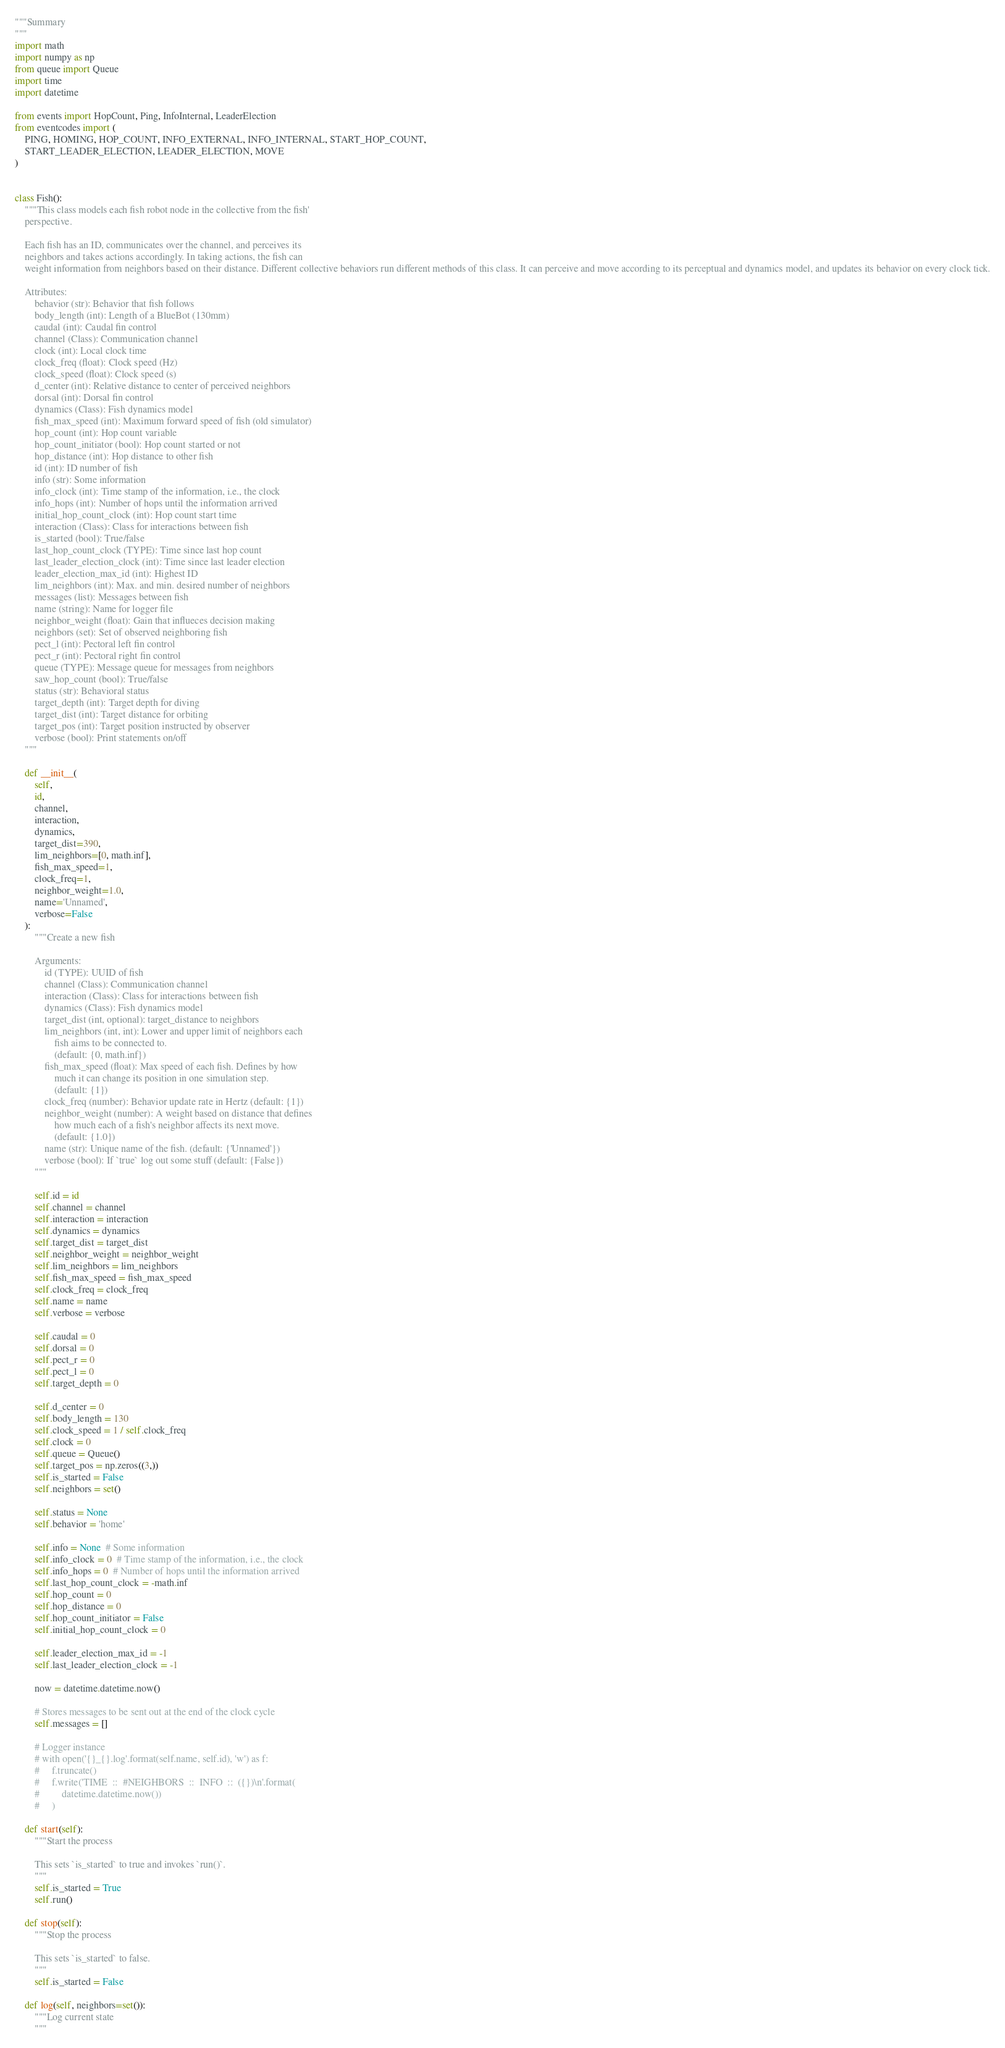<code> <loc_0><loc_0><loc_500><loc_500><_Python_>"""Summary
"""
import math
import numpy as np
from queue import Queue
import time
import datetime

from events import HopCount, Ping, InfoInternal, LeaderElection
from eventcodes import (
    PING, HOMING, HOP_COUNT, INFO_EXTERNAL, INFO_INTERNAL, START_HOP_COUNT,
    START_LEADER_ELECTION, LEADER_ELECTION, MOVE
)


class Fish():
    """This class models each fish robot node in the collective from the fish'
    perspective.

    Each fish has an ID, communicates over the channel, and perceives its
    neighbors and takes actions accordingly. In taking actions, the fish can
    weight information from neighbors based on their distance. Different collective behaviors run different methods of this class. It can perceive and move according to its perceptual and dynamics model, and updates its behavior on every clock tick.

    Attributes:
        behavior (str): Behavior that fish follows
        body_length (int): Length of a BlueBot (130mm)
        caudal (int): Caudal fin control
        channel (Class): Communication channel
        clock (int): Local clock time
        clock_freq (float): Clock speed (Hz)
        clock_speed (float): Clock speed (s)
        d_center (int): Relative distance to center of perceived neighbors
        dorsal (int): Dorsal fin control
        dynamics (Class): Fish dynamics model
        fish_max_speed (int): Maximum forward speed of fish (old simulator)
        hop_count (int): Hop count variable
        hop_count_initiator (bool): Hop count started or not
        hop_distance (int): Hop distance to other fish
        id (int): ID number of fish
        info (str): Some information
        info_clock (int): Time stamp of the information, i.e., the clock
        info_hops (int): Number of hops until the information arrived
        initial_hop_count_clock (int): Hop count start time
        interaction (Class): Class for interactions between fish
        is_started (bool): True/false
        last_hop_count_clock (TYPE): Time since last hop count
        last_leader_election_clock (int): Time since last leader election
        leader_election_max_id (int): Highest ID
        lim_neighbors (int): Max. and min. desired number of neighbors
        messages (list): Messages between fish
        name (string): Name for logger file
        neighbor_weight (float): Gain that influeces decision making
        neighbors (set): Set of observed neighboring fish
        pect_l (int): Pectoral left fin control
        pect_r (int): Pectoral right fin control
        queue (TYPE): Message queue for messages from neighbors
        saw_hop_count (bool): True/false
        status (str): Behavioral status
        target_depth (int): Target depth for diving
        target_dist (int): Target distance for orbiting
        target_pos (int): Target position instructed by observer
        verbose (bool): Print statements on/off
    """

    def __init__(
        self,
        id,
        channel,
        interaction,
        dynamics,
        target_dist=390,
        lim_neighbors=[0, math.inf],
        fish_max_speed=1,
        clock_freq=1,
        neighbor_weight=1.0,
        name='Unnamed',
        verbose=False
    ):
        """Create a new fish

        Arguments:
            id (TYPE): UUID of fish
            channel (Class): Communication channel
            interaction (Class): Class for interactions between fish
            dynamics (Class): Fish dynamics model
            target_dist (int, optional): target_distance to neighbors
            lim_neighbors (int, int): Lower and upper limit of neighbors each
                fish aims to be connected to.
                (default: {0, math.inf})
            fish_max_speed (float): Max speed of each fish. Defines by how
                much it can change its position in one simulation step.
                (default: {1})
            clock_freq (number): Behavior update rate in Hertz (default: {1})
            neighbor_weight (number): A weight based on distance that defines
                how much each of a fish's neighbor affects its next move.
                (default: {1.0})
            name (str): Unique name of the fish. (default: {'Unnamed'})
            verbose (bool): If `true` log out some stuff (default: {False})
        """

        self.id = id
        self.channel = channel
        self.interaction = interaction
        self.dynamics = dynamics
        self.target_dist = target_dist
        self.neighbor_weight = neighbor_weight
        self.lim_neighbors = lim_neighbors
        self.fish_max_speed = fish_max_speed
        self.clock_freq = clock_freq
        self.name = name
        self.verbose = verbose

        self.caudal = 0
        self.dorsal = 0
        self.pect_r = 0
        self.pect_l = 0
        self.target_depth = 0

        self.d_center = 0
        self.body_length = 130
        self.clock_speed = 1 / self.clock_freq
        self.clock = 0
        self.queue = Queue()
        self.target_pos = np.zeros((3,))
        self.is_started = False
        self.neighbors = set()

        self.status = None
        self.behavior = 'home'

        self.info = None  # Some information
        self.info_clock = 0  # Time stamp of the information, i.e., the clock
        self.info_hops = 0  # Number of hops until the information arrived
        self.last_hop_count_clock = -math.inf
        self.hop_count = 0
        self.hop_distance = 0
        self.hop_count_initiator = False
        self.initial_hop_count_clock = 0

        self.leader_election_max_id = -1
        self.last_leader_election_clock = -1

        now = datetime.datetime.now()

        # Stores messages to be sent out at the end of the clock cycle
        self.messages = []

        # Logger instance
        # with open('{}_{}.log'.format(self.name, self.id), 'w') as f:
        #     f.truncate()
        #     f.write('TIME  ::  #NEIGHBORS  ::  INFO  ::  ({})\n'.format(
        #         datetime.datetime.now())
        #     )

    def start(self):
        """Start the process

        This sets `is_started` to true and invokes `run()`.
        """
        self.is_started = True
        self.run()

    def stop(self):
        """Stop the process

        This sets `is_started` to false.
        """
        self.is_started = False

    def log(self, neighbors=set()):
        """Log current state
        """
</code> 